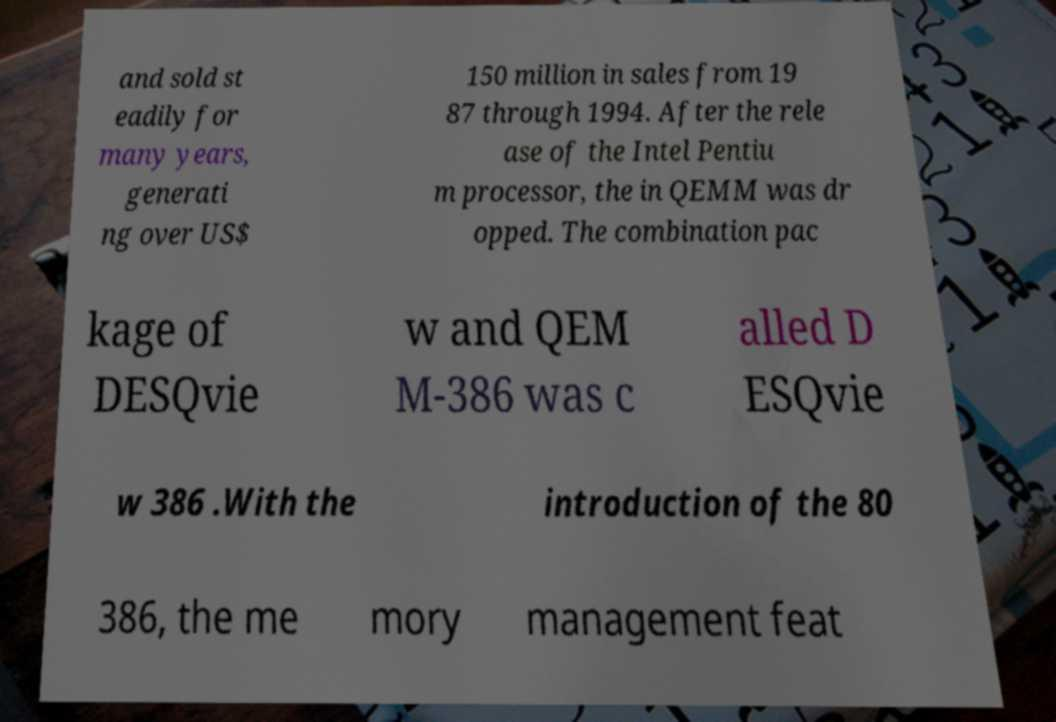What messages or text are displayed in this image? I need them in a readable, typed format. and sold st eadily for many years, generati ng over US$ 150 million in sales from 19 87 through 1994. After the rele ase of the Intel Pentiu m processor, the in QEMM was dr opped. The combination pac kage of DESQvie w and QEM M-386 was c alled D ESQvie w 386 .With the introduction of the 80 386, the me mory management feat 